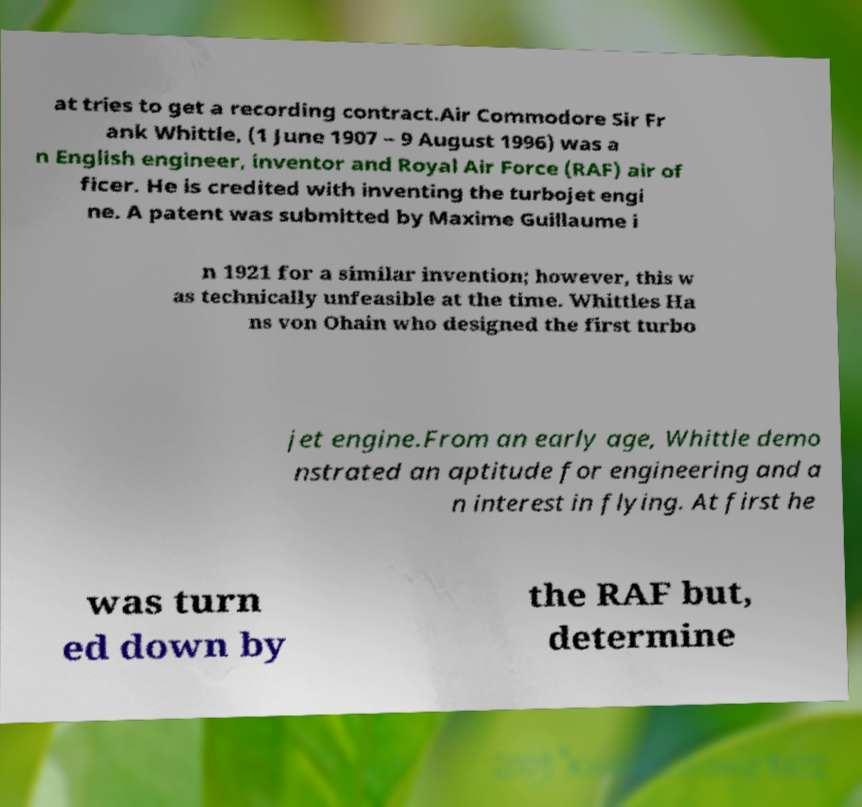Can you accurately transcribe the text from the provided image for me? at tries to get a recording contract.Air Commodore Sir Fr ank Whittle, (1 June 1907 – 9 August 1996) was a n English engineer, inventor and Royal Air Force (RAF) air of ficer. He is credited with inventing the turbojet engi ne. A patent was submitted by Maxime Guillaume i n 1921 for a similar invention; however, this w as technically unfeasible at the time. Whittles Ha ns von Ohain who designed the first turbo jet engine.From an early age, Whittle demo nstrated an aptitude for engineering and a n interest in flying. At first he was turn ed down by the RAF but, determine 